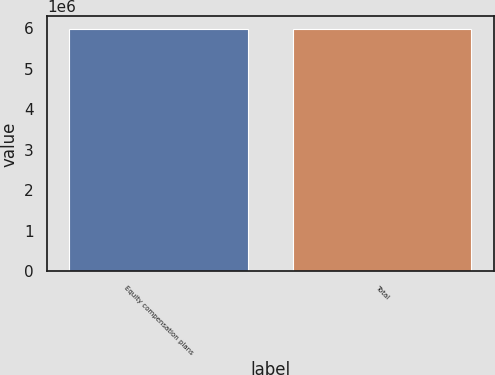Convert chart. <chart><loc_0><loc_0><loc_500><loc_500><bar_chart><fcel>Equity compensation plans<fcel>Total<nl><fcel>5.98401e+06<fcel>5.98401e+06<nl></chart> 